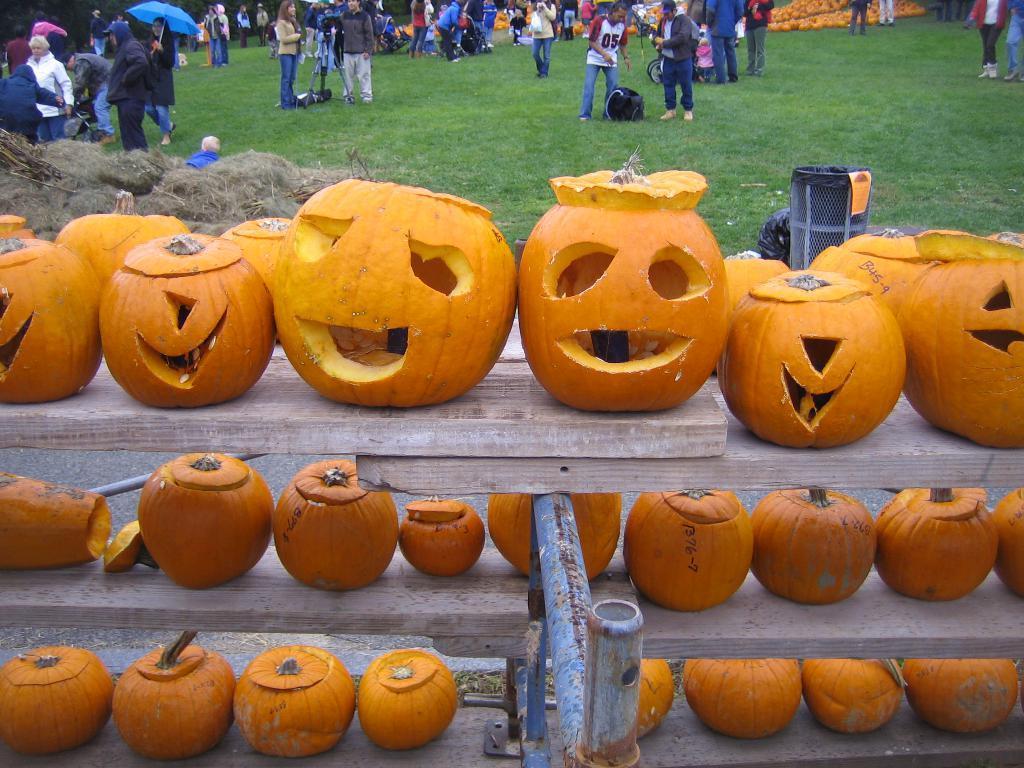Please provide a concise description of this image. In this picture I can see Halloween pumpkins on the wooden shelf. In the background I can see people and some other objects among them some people are holding umbrellas. I can also see some objects on the grass. 